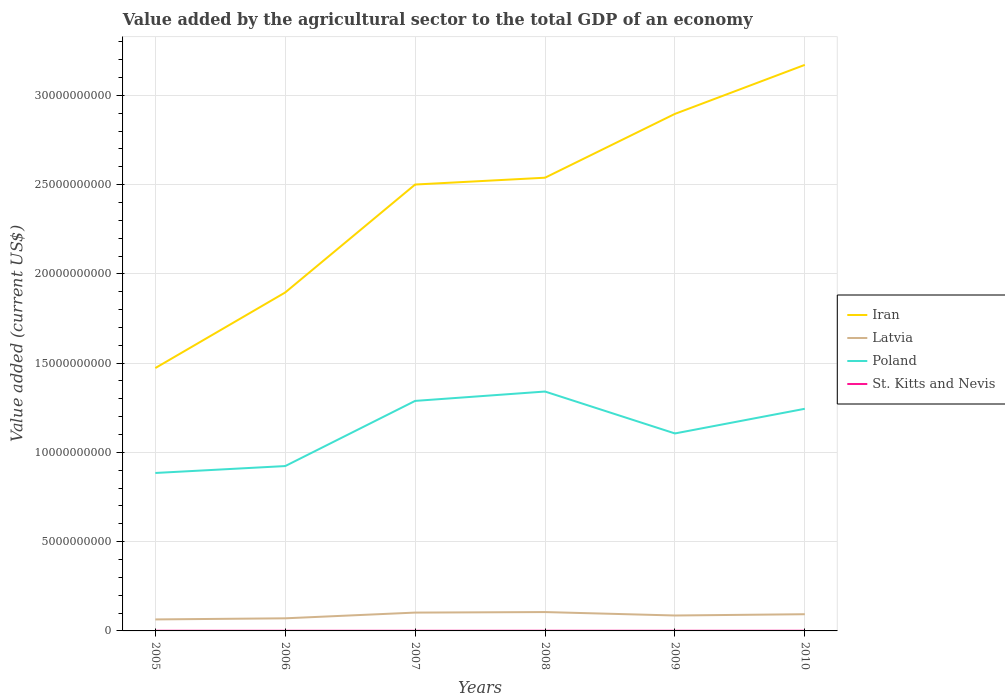How many different coloured lines are there?
Offer a very short reply. 4. Is the number of lines equal to the number of legend labels?
Offer a terse response. Yes. Across all years, what is the maximum value added by the agricultural sector to the total GDP in Latvia?
Offer a very short reply. 6.44e+08. What is the total value added by the agricultural sector to the total GDP in Iran in the graph?
Give a very brief answer. -1.03e+1. What is the difference between the highest and the second highest value added by the agricultural sector to the total GDP in Latvia?
Make the answer very short. 4.13e+08. What is the difference between the highest and the lowest value added by the agricultural sector to the total GDP in Poland?
Make the answer very short. 3. How many years are there in the graph?
Your response must be concise. 6. Are the values on the major ticks of Y-axis written in scientific E-notation?
Make the answer very short. No. Does the graph contain any zero values?
Provide a short and direct response. No. Where does the legend appear in the graph?
Keep it short and to the point. Center right. How are the legend labels stacked?
Your answer should be compact. Vertical. What is the title of the graph?
Provide a short and direct response. Value added by the agricultural sector to the total GDP of an economy. Does "Malawi" appear as one of the legend labels in the graph?
Your response must be concise. No. What is the label or title of the Y-axis?
Keep it short and to the point. Value added (current US$). What is the Value added (current US$) in Iran in 2005?
Give a very brief answer. 1.47e+1. What is the Value added (current US$) of Latvia in 2005?
Provide a short and direct response. 6.44e+08. What is the Value added (current US$) of Poland in 2005?
Your answer should be very brief. 8.85e+09. What is the Value added (current US$) of St. Kitts and Nevis in 2005?
Make the answer very short. 9.09e+06. What is the Value added (current US$) of Iran in 2006?
Make the answer very short. 1.90e+1. What is the Value added (current US$) of Latvia in 2006?
Your response must be concise. 7.06e+08. What is the Value added (current US$) of Poland in 2006?
Offer a terse response. 9.23e+09. What is the Value added (current US$) of St. Kitts and Nevis in 2006?
Make the answer very short. 7.66e+06. What is the Value added (current US$) of Iran in 2007?
Give a very brief answer. 2.50e+1. What is the Value added (current US$) in Latvia in 2007?
Make the answer very short. 1.03e+09. What is the Value added (current US$) of Poland in 2007?
Make the answer very short. 1.29e+1. What is the Value added (current US$) in St. Kitts and Nevis in 2007?
Offer a terse response. 7.96e+06. What is the Value added (current US$) of Iran in 2008?
Provide a short and direct response. 2.54e+1. What is the Value added (current US$) of Latvia in 2008?
Make the answer very short. 1.06e+09. What is the Value added (current US$) in Poland in 2008?
Make the answer very short. 1.34e+1. What is the Value added (current US$) of St. Kitts and Nevis in 2008?
Ensure brevity in your answer.  9.52e+06. What is the Value added (current US$) of Iran in 2009?
Your answer should be very brief. 2.90e+1. What is the Value added (current US$) of Latvia in 2009?
Provide a succinct answer. 8.64e+08. What is the Value added (current US$) of Poland in 2009?
Give a very brief answer. 1.11e+1. What is the Value added (current US$) in St. Kitts and Nevis in 2009?
Keep it short and to the point. 8.69e+06. What is the Value added (current US$) in Iran in 2010?
Provide a succinct answer. 3.17e+1. What is the Value added (current US$) of Latvia in 2010?
Your response must be concise. 9.36e+08. What is the Value added (current US$) of Poland in 2010?
Keep it short and to the point. 1.24e+1. What is the Value added (current US$) of St. Kitts and Nevis in 2010?
Your answer should be compact. 9.88e+06. Across all years, what is the maximum Value added (current US$) in Iran?
Provide a short and direct response. 3.17e+1. Across all years, what is the maximum Value added (current US$) of Latvia?
Offer a very short reply. 1.06e+09. Across all years, what is the maximum Value added (current US$) in Poland?
Your answer should be compact. 1.34e+1. Across all years, what is the maximum Value added (current US$) of St. Kitts and Nevis?
Keep it short and to the point. 9.88e+06. Across all years, what is the minimum Value added (current US$) of Iran?
Make the answer very short. 1.47e+1. Across all years, what is the minimum Value added (current US$) in Latvia?
Offer a very short reply. 6.44e+08. Across all years, what is the minimum Value added (current US$) of Poland?
Your answer should be compact. 8.85e+09. Across all years, what is the minimum Value added (current US$) in St. Kitts and Nevis?
Make the answer very short. 7.66e+06. What is the total Value added (current US$) in Iran in the graph?
Your answer should be very brief. 1.45e+11. What is the total Value added (current US$) of Latvia in the graph?
Provide a succinct answer. 5.23e+09. What is the total Value added (current US$) of Poland in the graph?
Offer a terse response. 6.79e+1. What is the total Value added (current US$) of St. Kitts and Nevis in the graph?
Offer a very short reply. 5.28e+07. What is the difference between the Value added (current US$) in Iran in 2005 and that in 2006?
Your response must be concise. -4.23e+09. What is the difference between the Value added (current US$) in Latvia in 2005 and that in 2006?
Offer a very short reply. -6.20e+07. What is the difference between the Value added (current US$) of Poland in 2005 and that in 2006?
Your answer should be compact. -3.87e+08. What is the difference between the Value added (current US$) of St. Kitts and Nevis in 2005 and that in 2006?
Keep it short and to the point. 1.43e+06. What is the difference between the Value added (current US$) of Iran in 2005 and that in 2007?
Your answer should be very brief. -1.03e+1. What is the difference between the Value added (current US$) of Latvia in 2005 and that in 2007?
Offer a terse response. -3.83e+08. What is the difference between the Value added (current US$) in Poland in 2005 and that in 2007?
Your answer should be very brief. -4.04e+09. What is the difference between the Value added (current US$) in St. Kitts and Nevis in 2005 and that in 2007?
Keep it short and to the point. 1.13e+06. What is the difference between the Value added (current US$) in Iran in 2005 and that in 2008?
Keep it short and to the point. -1.07e+1. What is the difference between the Value added (current US$) in Latvia in 2005 and that in 2008?
Your answer should be very brief. -4.13e+08. What is the difference between the Value added (current US$) in Poland in 2005 and that in 2008?
Offer a very short reply. -4.56e+09. What is the difference between the Value added (current US$) in St. Kitts and Nevis in 2005 and that in 2008?
Make the answer very short. -4.24e+05. What is the difference between the Value added (current US$) in Iran in 2005 and that in 2009?
Your answer should be very brief. -1.42e+1. What is the difference between the Value added (current US$) of Latvia in 2005 and that in 2009?
Your response must be concise. -2.20e+08. What is the difference between the Value added (current US$) in Poland in 2005 and that in 2009?
Your answer should be compact. -2.21e+09. What is the difference between the Value added (current US$) in St. Kitts and Nevis in 2005 and that in 2009?
Provide a succinct answer. 4.01e+05. What is the difference between the Value added (current US$) of Iran in 2005 and that in 2010?
Give a very brief answer. -1.70e+1. What is the difference between the Value added (current US$) in Latvia in 2005 and that in 2010?
Offer a terse response. -2.92e+08. What is the difference between the Value added (current US$) in Poland in 2005 and that in 2010?
Provide a short and direct response. -3.60e+09. What is the difference between the Value added (current US$) of St. Kitts and Nevis in 2005 and that in 2010?
Give a very brief answer. -7.87e+05. What is the difference between the Value added (current US$) of Iran in 2006 and that in 2007?
Your answer should be very brief. -6.05e+09. What is the difference between the Value added (current US$) in Latvia in 2006 and that in 2007?
Offer a terse response. -3.21e+08. What is the difference between the Value added (current US$) in Poland in 2006 and that in 2007?
Make the answer very short. -3.65e+09. What is the difference between the Value added (current US$) in St. Kitts and Nevis in 2006 and that in 2007?
Ensure brevity in your answer.  -3.03e+05. What is the difference between the Value added (current US$) of Iran in 2006 and that in 2008?
Your answer should be compact. -6.43e+09. What is the difference between the Value added (current US$) in Latvia in 2006 and that in 2008?
Give a very brief answer. -3.51e+08. What is the difference between the Value added (current US$) in Poland in 2006 and that in 2008?
Your answer should be compact. -4.17e+09. What is the difference between the Value added (current US$) in St. Kitts and Nevis in 2006 and that in 2008?
Your response must be concise. -1.86e+06. What is the difference between the Value added (current US$) of Iran in 2006 and that in 2009?
Offer a terse response. -1.00e+1. What is the difference between the Value added (current US$) in Latvia in 2006 and that in 2009?
Make the answer very short. -1.58e+08. What is the difference between the Value added (current US$) of Poland in 2006 and that in 2009?
Provide a short and direct response. -1.83e+09. What is the difference between the Value added (current US$) in St. Kitts and Nevis in 2006 and that in 2009?
Make the answer very short. -1.03e+06. What is the difference between the Value added (current US$) of Iran in 2006 and that in 2010?
Ensure brevity in your answer.  -1.27e+1. What is the difference between the Value added (current US$) of Latvia in 2006 and that in 2010?
Your answer should be very brief. -2.30e+08. What is the difference between the Value added (current US$) in Poland in 2006 and that in 2010?
Make the answer very short. -3.21e+09. What is the difference between the Value added (current US$) in St. Kitts and Nevis in 2006 and that in 2010?
Offer a very short reply. -2.22e+06. What is the difference between the Value added (current US$) in Iran in 2007 and that in 2008?
Provide a short and direct response. -3.82e+08. What is the difference between the Value added (current US$) in Latvia in 2007 and that in 2008?
Give a very brief answer. -2.97e+07. What is the difference between the Value added (current US$) in Poland in 2007 and that in 2008?
Your answer should be compact. -5.25e+08. What is the difference between the Value added (current US$) in St. Kitts and Nevis in 2007 and that in 2008?
Provide a short and direct response. -1.55e+06. What is the difference between the Value added (current US$) of Iran in 2007 and that in 2009?
Make the answer very short. -3.96e+09. What is the difference between the Value added (current US$) in Latvia in 2007 and that in 2009?
Provide a succinct answer. 1.63e+08. What is the difference between the Value added (current US$) in Poland in 2007 and that in 2009?
Offer a terse response. 1.82e+09. What is the difference between the Value added (current US$) of St. Kitts and Nevis in 2007 and that in 2009?
Ensure brevity in your answer.  -7.28e+05. What is the difference between the Value added (current US$) in Iran in 2007 and that in 2010?
Keep it short and to the point. -6.70e+09. What is the difference between the Value added (current US$) in Latvia in 2007 and that in 2010?
Your response must be concise. 9.11e+07. What is the difference between the Value added (current US$) of Poland in 2007 and that in 2010?
Give a very brief answer. 4.42e+08. What is the difference between the Value added (current US$) of St. Kitts and Nevis in 2007 and that in 2010?
Offer a very short reply. -1.92e+06. What is the difference between the Value added (current US$) in Iran in 2008 and that in 2009?
Your answer should be very brief. -3.58e+09. What is the difference between the Value added (current US$) in Latvia in 2008 and that in 2009?
Your response must be concise. 1.92e+08. What is the difference between the Value added (current US$) in Poland in 2008 and that in 2009?
Offer a terse response. 2.35e+09. What is the difference between the Value added (current US$) of St. Kitts and Nevis in 2008 and that in 2009?
Your response must be concise. 8.25e+05. What is the difference between the Value added (current US$) in Iran in 2008 and that in 2010?
Keep it short and to the point. -6.32e+09. What is the difference between the Value added (current US$) of Latvia in 2008 and that in 2010?
Offer a very short reply. 1.21e+08. What is the difference between the Value added (current US$) in Poland in 2008 and that in 2010?
Provide a short and direct response. 9.66e+08. What is the difference between the Value added (current US$) of St. Kitts and Nevis in 2008 and that in 2010?
Provide a succinct answer. -3.63e+05. What is the difference between the Value added (current US$) of Iran in 2009 and that in 2010?
Your answer should be compact. -2.75e+09. What is the difference between the Value added (current US$) in Latvia in 2009 and that in 2010?
Keep it short and to the point. -7.16e+07. What is the difference between the Value added (current US$) in Poland in 2009 and that in 2010?
Ensure brevity in your answer.  -1.38e+09. What is the difference between the Value added (current US$) in St. Kitts and Nevis in 2009 and that in 2010?
Offer a very short reply. -1.19e+06. What is the difference between the Value added (current US$) in Iran in 2005 and the Value added (current US$) in Latvia in 2006?
Provide a succinct answer. 1.40e+1. What is the difference between the Value added (current US$) in Iran in 2005 and the Value added (current US$) in Poland in 2006?
Keep it short and to the point. 5.49e+09. What is the difference between the Value added (current US$) of Iran in 2005 and the Value added (current US$) of St. Kitts and Nevis in 2006?
Ensure brevity in your answer.  1.47e+1. What is the difference between the Value added (current US$) of Latvia in 2005 and the Value added (current US$) of Poland in 2006?
Your answer should be very brief. -8.59e+09. What is the difference between the Value added (current US$) of Latvia in 2005 and the Value added (current US$) of St. Kitts and Nevis in 2006?
Ensure brevity in your answer.  6.36e+08. What is the difference between the Value added (current US$) in Poland in 2005 and the Value added (current US$) in St. Kitts and Nevis in 2006?
Your response must be concise. 8.84e+09. What is the difference between the Value added (current US$) in Iran in 2005 and the Value added (current US$) in Latvia in 2007?
Ensure brevity in your answer.  1.37e+1. What is the difference between the Value added (current US$) of Iran in 2005 and the Value added (current US$) of Poland in 2007?
Offer a very short reply. 1.84e+09. What is the difference between the Value added (current US$) of Iran in 2005 and the Value added (current US$) of St. Kitts and Nevis in 2007?
Offer a very short reply. 1.47e+1. What is the difference between the Value added (current US$) of Latvia in 2005 and the Value added (current US$) of Poland in 2007?
Ensure brevity in your answer.  -1.22e+1. What is the difference between the Value added (current US$) in Latvia in 2005 and the Value added (current US$) in St. Kitts and Nevis in 2007?
Keep it short and to the point. 6.36e+08. What is the difference between the Value added (current US$) in Poland in 2005 and the Value added (current US$) in St. Kitts and Nevis in 2007?
Provide a short and direct response. 8.84e+09. What is the difference between the Value added (current US$) in Iran in 2005 and the Value added (current US$) in Latvia in 2008?
Your response must be concise. 1.37e+1. What is the difference between the Value added (current US$) of Iran in 2005 and the Value added (current US$) of Poland in 2008?
Offer a terse response. 1.32e+09. What is the difference between the Value added (current US$) in Iran in 2005 and the Value added (current US$) in St. Kitts and Nevis in 2008?
Keep it short and to the point. 1.47e+1. What is the difference between the Value added (current US$) in Latvia in 2005 and the Value added (current US$) in Poland in 2008?
Make the answer very short. -1.28e+1. What is the difference between the Value added (current US$) in Latvia in 2005 and the Value added (current US$) in St. Kitts and Nevis in 2008?
Make the answer very short. 6.34e+08. What is the difference between the Value added (current US$) in Poland in 2005 and the Value added (current US$) in St. Kitts and Nevis in 2008?
Your answer should be compact. 8.84e+09. What is the difference between the Value added (current US$) of Iran in 2005 and the Value added (current US$) of Latvia in 2009?
Provide a succinct answer. 1.39e+1. What is the difference between the Value added (current US$) in Iran in 2005 and the Value added (current US$) in Poland in 2009?
Ensure brevity in your answer.  3.66e+09. What is the difference between the Value added (current US$) in Iran in 2005 and the Value added (current US$) in St. Kitts and Nevis in 2009?
Your answer should be compact. 1.47e+1. What is the difference between the Value added (current US$) in Latvia in 2005 and the Value added (current US$) in Poland in 2009?
Provide a succinct answer. -1.04e+1. What is the difference between the Value added (current US$) in Latvia in 2005 and the Value added (current US$) in St. Kitts and Nevis in 2009?
Your answer should be compact. 6.35e+08. What is the difference between the Value added (current US$) of Poland in 2005 and the Value added (current US$) of St. Kitts and Nevis in 2009?
Keep it short and to the point. 8.84e+09. What is the difference between the Value added (current US$) in Iran in 2005 and the Value added (current US$) in Latvia in 2010?
Keep it short and to the point. 1.38e+1. What is the difference between the Value added (current US$) in Iran in 2005 and the Value added (current US$) in Poland in 2010?
Keep it short and to the point. 2.28e+09. What is the difference between the Value added (current US$) of Iran in 2005 and the Value added (current US$) of St. Kitts and Nevis in 2010?
Give a very brief answer. 1.47e+1. What is the difference between the Value added (current US$) of Latvia in 2005 and the Value added (current US$) of Poland in 2010?
Offer a terse response. -1.18e+1. What is the difference between the Value added (current US$) of Latvia in 2005 and the Value added (current US$) of St. Kitts and Nevis in 2010?
Your response must be concise. 6.34e+08. What is the difference between the Value added (current US$) in Poland in 2005 and the Value added (current US$) in St. Kitts and Nevis in 2010?
Provide a short and direct response. 8.84e+09. What is the difference between the Value added (current US$) in Iran in 2006 and the Value added (current US$) in Latvia in 2007?
Your answer should be very brief. 1.79e+1. What is the difference between the Value added (current US$) of Iran in 2006 and the Value added (current US$) of Poland in 2007?
Your answer should be compact. 6.07e+09. What is the difference between the Value added (current US$) in Iran in 2006 and the Value added (current US$) in St. Kitts and Nevis in 2007?
Ensure brevity in your answer.  1.90e+1. What is the difference between the Value added (current US$) in Latvia in 2006 and the Value added (current US$) in Poland in 2007?
Give a very brief answer. -1.22e+1. What is the difference between the Value added (current US$) of Latvia in 2006 and the Value added (current US$) of St. Kitts and Nevis in 2007?
Keep it short and to the point. 6.98e+08. What is the difference between the Value added (current US$) of Poland in 2006 and the Value added (current US$) of St. Kitts and Nevis in 2007?
Offer a very short reply. 9.23e+09. What is the difference between the Value added (current US$) of Iran in 2006 and the Value added (current US$) of Latvia in 2008?
Provide a short and direct response. 1.79e+1. What is the difference between the Value added (current US$) of Iran in 2006 and the Value added (current US$) of Poland in 2008?
Provide a short and direct response. 5.55e+09. What is the difference between the Value added (current US$) in Iran in 2006 and the Value added (current US$) in St. Kitts and Nevis in 2008?
Offer a very short reply. 1.89e+1. What is the difference between the Value added (current US$) in Latvia in 2006 and the Value added (current US$) in Poland in 2008?
Your answer should be very brief. -1.27e+1. What is the difference between the Value added (current US$) of Latvia in 2006 and the Value added (current US$) of St. Kitts and Nevis in 2008?
Offer a very short reply. 6.96e+08. What is the difference between the Value added (current US$) of Poland in 2006 and the Value added (current US$) of St. Kitts and Nevis in 2008?
Offer a very short reply. 9.22e+09. What is the difference between the Value added (current US$) in Iran in 2006 and the Value added (current US$) in Latvia in 2009?
Your answer should be very brief. 1.81e+1. What is the difference between the Value added (current US$) of Iran in 2006 and the Value added (current US$) of Poland in 2009?
Your answer should be compact. 7.90e+09. What is the difference between the Value added (current US$) of Iran in 2006 and the Value added (current US$) of St. Kitts and Nevis in 2009?
Your answer should be compact. 1.90e+1. What is the difference between the Value added (current US$) of Latvia in 2006 and the Value added (current US$) of Poland in 2009?
Keep it short and to the point. -1.04e+1. What is the difference between the Value added (current US$) in Latvia in 2006 and the Value added (current US$) in St. Kitts and Nevis in 2009?
Your response must be concise. 6.97e+08. What is the difference between the Value added (current US$) of Poland in 2006 and the Value added (current US$) of St. Kitts and Nevis in 2009?
Offer a terse response. 9.23e+09. What is the difference between the Value added (current US$) of Iran in 2006 and the Value added (current US$) of Latvia in 2010?
Provide a short and direct response. 1.80e+1. What is the difference between the Value added (current US$) of Iran in 2006 and the Value added (current US$) of Poland in 2010?
Provide a short and direct response. 6.52e+09. What is the difference between the Value added (current US$) in Iran in 2006 and the Value added (current US$) in St. Kitts and Nevis in 2010?
Keep it short and to the point. 1.89e+1. What is the difference between the Value added (current US$) of Latvia in 2006 and the Value added (current US$) of Poland in 2010?
Offer a terse response. -1.17e+1. What is the difference between the Value added (current US$) of Latvia in 2006 and the Value added (current US$) of St. Kitts and Nevis in 2010?
Offer a terse response. 6.96e+08. What is the difference between the Value added (current US$) in Poland in 2006 and the Value added (current US$) in St. Kitts and Nevis in 2010?
Your answer should be compact. 9.22e+09. What is the difference between the Value added (current US$) of Iran in 2007 and the Value added (current US$) of Latvia in 2008?
Your answer should be very brief. 2.39e+1. What is the difference between the Value added (current US$) in Iran in 2007 and the Value added (current US$) in Poland in 2008?
Provide a short and direct response. 1.16e+1. What is the difference between the Value added (current US$) of Iran in 2007 and the Value added (current US$) of St. Kitts and Nevis in 2008?
Offer a terse response. 2.50e+1. What is the difference between the Value added (current US$) in Latvia in 2007 and the Value added (current US$) in Poland in 2008?
Provide a succinct answer. -1.24e+1. What is the difference between the Value added (current US$) in Latvia in 2007 and the Value added (current US$) in St. Kitts and Nevis in 2008?
Offer a terse response. 1.02e+09. What is the difference between the Value added (current US$) in Poland in 2007 and the Value added (current US$) in St. Kitts and Nevis in 2008?
Provide a short and direct response. 1.29e+1. What is the difference between the Value added (current US$) in Iran in 2007 and the Value added (current US$) in Latvia in 2009?
Your answer should be very brief. 2.41e+1. What is the difference between the Value added (current US$) in Iran in 2007 and the Value added (current US$) in Poland in 2009?
Provide a short and direct response. 1.39e+1. What is the difference between the Value added (current US$) in Iran in 2007 and the Value added (current US$) in St. Kitts and Nevis in 2009?
Ensure brevity in your answer.  2.50e+1. What is the difference between the Value added (current US$) in Latvia in 2007 and the Value added (current US$) in Poland in 2009?
Give a very brief answer. -1.00e+1. What is the difference between the Value added (current US$) in Latvia in 2007 and the Value added (current US$) in St. Kitts and Nevis in 2009?
Your answer should be very brief. 1.02e+09. What is the difference between the Value added (current US$) of Poland in 2007 and the Value added (current US$) of St. Kitts and Nevis in 2009?
Your response must be concise. 1.29e+1. What is the difference between the Value added (current US$) in Iran in 2007 and the Value added (current US$) in Latvia in 2010?
Your answer should be compact. 2.41e+1. What is the difference between the Value added (current US$) of Iran in 2007 and the Value added (current US$) of Poland in 2010?
Give a very brief answer. 1.26e+1. What is the difference between the Value added (current US$) of Iran in 2007 and the Value added (current US$) of St. Kitts and Nevis in 2010?
Ensure brevity in your answer.  2.50e+1. What is the difference between the Value added (current US$) in Latvia in 2007 and the Value added (current US$) in Poland in 2010?
Provide a short and direct response. -1.14e+1. What is the difference between the Value added (current US$) of Latvia in 2007 and the Value added (current US$) of St. Kitts and Nevis in 2010?
Provide a short and direct response. 1.02e+09. What is the difference between the Value added (current US$) in Poland in 2007 and the Value added (current US$) in St. Kitts and Nevis in 2010?
Your response must be concise. 1.29e+1. What is the difference between the Value added (current US$) in Iran in 2008 and the Value added (current US$) in Latvia in 2009?
Offer a very short reply. 2.45e+1. What is the difference between the Value added (current US$) in Iran in 2008 and the Value added (current US$) in Poland in 2009?
Offer a terse response. 1.43e+1. What is the difference between the Value added (current US$) of Iran in 2008 and the Value added (current US$) of St. Kitts and Nevis in 2009?
Your answer should be very brief. 2.54e+1. What is the difference between the Value added (current US$) in Latvia in 2008 and the Value added (current US$) in Poland in 2009?
Give a very brief answer. -1.00e+1. What is the difference between the Value added (current US$) of Latvia in 2008 and the Value added (current US$) of St. Kitts and Nevis in 2009?
Your answer should be compact. 1.05e+09. What is the difference between the Value added (current US$) in Poland in 2008 and the Value added (current US$) in St. Kitts and Nevis in 2009?
Ensure brevity in your answer.  1.34e+1. What is the difference between the Value added (current US$) of Iran in 2008 and the Value added (current US$) of Latvia in 2010?
Provide a short and direct response. 2.45e+1. What is the difference between the Value added (current US$) in Iran in 2008 and the Value added (current US$) in Poland in 2010?
Make the answer very short. 1.29e+1. What is the difference between the Value added (current US$) of Iran in 2008 and the Value added (current US$) of St. Kitts and Nevis in 2010?
Your answer should be compact. 2.54e+1. What is the difference between the Value added (current US$) of Latvia in 2008 and the Value added (current US$) of Poland in 2010?
Make the answer very short. -1.14e+1. What is the difference between the Value added (current US$) of Latvia in 2008 and the Value added (current US$) of St. Kitts and Nevis in 2010?
Offer a very short reply. 1.05e+09. What is the difference between the Value added (current US$) of Poland in 2008 and the Value added (current US$) of St. Kitts and Nevis in 2010?
Ensure brevity in your answer.  1.34e+1. What is the difference between the Value added (current US$) in Iran in 2009 and the Value added (current US$) in Latvia in 2010?
Offer a very short reply. 2.80e+1. What is the difference between the Value added (current US$) in Iran in 2009 and the Value added (current US$) in Poland in 2010?
Keep it short and to the point. 1.65e+1. What is the difference between the Value added (current US$) in Iran in 2009 and the Value added (current US$) in St. Kitts and Nevis in 2010?
Your answer should be very brief. 2.90e+1. What is the difference between the Value added (current US$) in Latvia in 2009 and the Value added (current US$) in Poland in 2010?
Your response must be concise. -1.16e+1. What is the difference between the Value added (current US$) of Latvia in 2009 and the Value added (current US$) of St. Kitts and Nevis in 2010?
Offer a very short reply. 8.54e+08. What is the difference between the Value added (current US$) of Poland in 2009 and the Value added (current US$) of St. Kitts and Nevis in 2010?
Offer a very short reply. 1.11e+1. What is the average Value added (current US$) in Iran per year?
Provide a short and direct response. 2.41e+1. What is the average Value added (current US$) in Latvia per year?
Keep it short and to the point. 8.72e+08. What is the average Value added (current US$) of Poland per year?
Make the answer very short. 1.13e+1. What is the average Value added (current US$) of St. Kitts and Nevis per year?
Keep it short and to the point. 8.80e+06. In the year 2005, what is the difference between the Value added (current US$) in Iran and Value added (current US$) in Latvia?
Ensure brevity in your answer.  1.41e+1. In the year 2005, what is the difference between the Value added (current US$) in Iran and Value added (current US$) in Poland?
Provide a succinct answer. 5.88e+09. In the year 2005, what is the difference between the Value added (current US$) in Iran and Value added (current US$) in St. Kitts and Nevis?
Your answer should be compact. 1.47e+1. In the year 2005, what is the difference between the Value added (current US$) of Latvia and Value added (current US$) of Poland?
Your answer should be compact. -8.20e+09. In the year 2005, what is the difference between the Value added (current US$) in Latvia and Value added (current US$) in St. Kitts and Nevis?
Provide a short and direct response. 6.35e+08. In the year 2005, what is the difference between the Value added (current US$) in Poland and Value added (current US$) in St. Kitts and Nevis?
Keep it short and to the point. 8.84e+09. In the year 2006, what is the difference between the Value added (current US$) of Iran and Value added (current US$) of Latvia?
Give a very brief answer. 1.83e+1. In the year 2006, what is the difference between the Value added (current US$) in Iran and Value added (current US$) in Poland?
Your answer should be compact. 9.72e+09. In the year 2006, what is the difference between the Value added (current US$) of Iran and Value added (current US$) of St. Kitts and Nevis?
Offer a very short reply. 1.90e+1. In the year 2006, what is the difference between the Value added (current US$) of Latvia and Value added (current US$) of Poland?
Provide a short and direct response. -8.53e+09. In the year 2006, what is the difference between the Value added (current US$) of Latvia and Value added (current US$) of St. Kitts and Nevis?
Make the answer very short. 6.98e+08. In the year 2006, what is the difference between the Value added (current US$) in Poland and Value added (current US$) in St. Kitts and Nevis?
Your answer should be compact. 9.23e+09. In the year 2007, what is the difference between the Value added (current US$) of Iran and Value added (current US$) of Latvia?
Ensure brevity in your answer.  2.40e+1. In the year 2007, what is the difference between the Value added (current US$) in Iran and Value added (current US$) in Poland?
Give a very brief answer. 1.21e+1. In the year 2007, what is the difference between the Value added (current US$) of Iran and Value added (current US$) of St. Kitts and Nevis?
Your answer should be very brief. 2.50e+1. In the year 2007, what is the difference between the Value added (current US$) of Latvia and Value added (current US$) of Poland?
Give a very brief answer. -1.19e+1. In the year 2007, what is the difference between the Value added (current US$) in Latvia and Value added (current US$) in St. Kitts and Nevis?
Offer a terse response. 1.02e+09. In the year 2007, what is the difference between the Value added (current US$) of Poland and Value added (current US$) of St. Kitts and Nevis?
Make the answer very short. 1.29e+1. In the year 2008, what is the difference between the Value added (current US$) in Iran and Value added (current US$) in Latvia?
Your answer should be compact. 2.43e+1. In the year 2008, what is the difference between the Value added (current US$) in Iran and Value added (current US$) in Poland?
Offer a very short reply. 1.20e+1. In the year 2008, what is the difference between the Value added (current US$) in Iran and Value added (current US$) in St. Kitts and Nevis?
Make the answer very short. 2.54e+1. In the year 2008, what is the difference between the Value added (current US$) of Latvia and Value added (current US$) of Poland?
Provide a succinct answer. -1.24e+1. In the year 2008, what is the difference between the Value added (current US$) in Latvia and Value added (current US$) in St. Kitts and Nevis?
Make the answer very short. 1.05e+09. In the year 2008, what is the difference between the Value added (current US$) in Poland and Value added (current US$) in St. Kitts and Nevis?
Provide a succinct answer. 1.34e+1. In the year 2009, what is the difference between the Value added (current US$) of Iran and Value added (current US$) of Latvia?
Your answer should be very brief. 2.81e+1. In the year 2009, what is the difference between the Value added (current US$) of Iran and Value added (current US$) of Poland?
Offer a terse response. 1.79e+1. In the year 2009, what is the difference between the Value added (current US$) in Iran and Value added (current US$) in St. Kitts and Nevis?
Make the answer very short. 2.90e+1. In the year 2009, what is the difference between the Value added (current US$) in Latvia and Value added (current US$) in Poland?
Give a very brief answer. -1.02e+1. In the year 2009, what is the difference between the Value added (current US$) in Latvia and Value added (current US$) in St. Kitts and Nevis?
Your answer should be very brief. 8.56e+08. In the year 2009, what is the difference between the Value added (current US$) in Poland and Value added (current US$) in St. Kitts and Nevis?
Keep it short and to the point. 1.11e+1. In the year 2010, what is the difference between the Value added (current US$) of Iran and Value added (current US$) of Latvia?
Provide a short and direct response. 3.08e+1. In the year 2010, what is the difference between the Value added (current US$) of Iran and Value added (current US$) of Poland?
Make the answer very short. 1.93e+1. In the year 2010, what is the difference between the Value added (current US$) in Iran and Value added (current US$) in St. Kitts and Nevis?
Your answer should be compact. 3.17e+1. In the year 2010, what is the difference between the Value added (current US$) in Latvia and Value added (current US$) in Poland?
Make the answer very short. -1.15e+1. In the year 2010, what is the difference between the Value added (current US$) of Latvia and Value added (current US$) of St. Kitts and Nevis?
Ensure brevity in your answer.  9.26e+08. In the year 2010, what is the difference between the Value added (current US$) in Poland and Value added (current US$) in St. Kitts and Nevis?
Ensure brevity in your answer.  1.24e+1. What is the ratio of the Value added (current US$) of Iran in 2005 to that in 2006?
Make the answer very short. 0.78. What is the ratio of the Value added (current US$) in Latvia in 2005 to that in 2006?
Your answer should be very brief. 0.91. What is the ratio of the Value added (current US$) in Poland in 2005 to that in 2006?
Ensure brevity in your answer.  0.96. What is the ratio of the Value added (current US$) of St. Kitts and Nevis in 2005 to that in 2006?
Keep it short and to the point. 1.19. What is the ratio of the Value added (current US$) of Iran in 2005 to that in 2007?
Provide a short and direct response. 0.59. What is the ratio of the Value added (current US$) in Latvia in 2005 to that in 2007?
Offer a terse response. 0.63. What is the ratio of the Value added (current US$) in Poland in 2005 to that in 2007?
Make the answer very short. 0.69. What is the ratio of the Value added (current US$) in St. Kitts and Nevis in 2005 to that in 2007?
Ensure brevity in your answer.  1.14. What is the ratio of the Value added (current US$) of Iran in 2005 to that in 2008?
Your response must be concise. 0.58. What is the ratio of the Value added (current US$) of Latvia in 2005 to that in 2008?
Offer a terse response. 0.61. What is the ratio of the Value added (current US$) in Poland in 2005 to that in 2008?
Your answer should be very brief. 0.66. What is the ratio of the Value added (current US$) in St. Kitts and Nevis in 2005 to that in 2008?
Your answer should be very brief. 0.96. What is the ratio of the Value added (current US$) of Iran in 2005 to that in 2009?
Your answer should be compact. 0.51. What is the ratio of the Value added (current US$) of Latvia in 2005 to that in 2009?
Provide a succinct answer. 0.75. What is the ratio of the Value added (current US$) of Poland in 2005 to that in 2009?
Offer a terse response. 0.8. What is the ratio of the Value added (current US$) in St. Kitts and Nevis in 2005 to that in 2009?
Provide a succinct answer. 1.05. What is the ratio of the Value added (current US$) in Iran in 2005 to that in 2010?
Your answer should be very brief. 0.46. What is the ratio of the Value added (current US$) in Latvia in 2005 to that in 2010?
Ensure brevity in your answer.  0.69. What is the ratio of the Value added (current US$) of Poland in 2005 to that in 2010?
Offer a terse response. 0.71. What is the ratio of the Value added (current US$) in St. Kitts and Nevis in 2005 to that in 2010?
Offer a very short reply. 0.92. What is the ratio of the Value added (current US$) of Iran in 2006 to that in 2007?
Make the answer very short. 0.76. What is the ratio of the Value added (current US$) in Latvia in 2006 to that in 2007?
Ensure brevity in your answer.  0.69. What is the ratio of the Value added (current US$) in Poland in 2006 to that in 2007?
Ensure brevity in your answer.  0.72. What is the ratio of the Value added (current US$) in St. Kitts and Nevis in 2006 to that in 2007?
Offer a very short reply. 0.96. What is the ratio of the Value added (current US$) in Iran in 2006 to that in 2008?
Provide a succinct answer. 0.75. What is the ratio of the Value added (current US$) of Latvia in 2006 to that in 2008?
Provide a short and direct response. 0.67. What is the ratio of the Value added (current US$) in Poland in 2006 to that in 2008?
Provide a succinct answer. 0.69. What is the ratio of the Value added (current US$) in St. Kitts and Nevis in 2006 to that in 2008?
Make the answer very short. 0.8. What is the ratio of the Value added (current US$) of Iran in 2006 to that in 2009?
Your answer should be very brief. 0.65. What is the ratio of the Value added (current US$) in Latvia in 2006 to that in 2009?
Provide a short and direct response. 0.82. What is the ratio of the Value added (current US$) of Poland in 2006 to that in 2009?
Offer a terse response. 0.83. What is the ratio of the Value added (current US$) in St. Kitts and Nevis in 2006 to that in 2009?
Your answer should be very brief. 0.88. What is the ratio of the Value added (current US$) of Iran in 2006 to that in 2010?
Ensure brevity in your answer.  0.6. What is the ratio of the Value added (current US$) of Latvia in 2006 to that in 2010?
Provide a short and direct response. 0.75. What is the ratio of the Value added (current US$) in Poland in 2006 to that in 2010?
Make the answer very short. 0.74. What is the ratio of the Value added (current US$) in St. Kitts and Nevis in 2006 to that in 2010?
Your response must be concise. 0.78. What is the ratio of the Value added (current US$) in Latvia in 2007 to that in 2008?
Your answer should be compact. 0.97. What is the ratio of the Value added (current US$) of Poland in 2007 to that in 2008?
Offer a terse response. 0.96. What is the ratio of the Value added (current US$) of St. Kitts and Nevis in 2007 to that in 2008?
Provide a succinct answer. 0.84. What is the ratio of the Value added (current US$) in Iran in 2007 to that in 2009?
Make the answer very short. 0.86. What is the ratio of the Value added (current US$) of Latvia in 2007 to that in 2009?
Ensure brevity in your answer.  1.19. What is the ratio of the Value added (current US$) of Poland in 2007 to that in 2009?
Offer a terse response. 1.16. What is the ratio of the Value added (current US$) of St. Kitts and Nevis in 2007 to that in 2009?
Your response must be concise. 0.92. What is the ratio of the Value added (current US$) in Iran in 2007 to that in 2010?
Offer a very short reply. 0.79. What is the ratio of the Value added (current US$) of Latvia in 2007 to that in 2010?
Keep it short and to the point. 1.1. What is the ratio of the Value added (current US$) of Poland in 2007 to that in 2010?
Offer a terse response. 1.04. What is the ratio of the Value added (current US$) in St. Kitts and Nevis in 2007 to that in 2010?
Provide a succinct answer. 0.81. What is the ratio of the Value added (current US$) in Iran in 2008 to that in 2009?
Offer a very short reply. 0.88. What is the ratio of the Value added (current US$) of Latvia in 2008 to that in 2009?
Give a very brief answer. 1.22. What is the ratio of the Value added (current US$) of Poland in 2008 to that in 2009?
Give a very brief answer. 1.21. What is the ratio of the Value added (current US$) of St. Kitts and Nevis in 2008 to that in 2009?
Your answer should be very brief. 1.09. What is the ratio of the Value added (current US$) of Iran in 2008 to that in 2010?
Provide a short and direct response. 0.8. What is the ratio of the Value added (current US$) of Latvia in 2008 to that in 2010?
Make the answer very short. 1.13. What is the ratio of the Value added (current US$) of Poland in 2008 to that in 2010?
Your response must be concise. 1.08. What is the ratio of the Value added (current US$) of St. Kitts and Nevis in 2008 to that in 2010?
Your response must be concise. 0.96. What is the ratio of the Value added (current US$) in Iran in 2009 to that in 2010?
Give a very brief answer. 0.91. What is the ratio of the Value added (current US$) in Latvia in 2009 to that in 2010?
Your answer should be very brief. 0.92. What is the ratio of the Value added (current US$) of St. Kitts and Nevis in 2009 to that in 2010?
Your answer should be very brief. 0.88. What is the difference between the highest and the second highest Value added (current US$) in Iran?
Make the answer very short. 2.75e+09. What is the difference between the highest and the second highest Value added (current US$) in Latvia?
Give a very brief answer. 2.97e+07. What is the difference between the highest and the second highest Value added (current US$) in Poland?
Make the answer very short. 5.25e+08. What is the difference between the highest and the second highest Value added (current US$) of St. Kitts and Nevis?
Your response must be concise. 3.63e+05. What is the difference between the highest and the lowest Value added (current US$) in Iran?
Provide a short and direct response. 1.70e+1. What is the difference between the highest and the lowest Value added (current US$) in Latvia?
Your answer should be compact. 4.13e+08. What is the difference between the highest and the lowest Value added (current US$) of Poland?
Your answer should be very brief. 4.56e+09. What is the difference between the highest and the lowest Value added (current US$) in St. Kitts and Nevis?
Make the answer very short. 2.22e+06. 